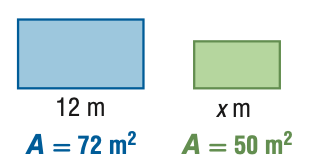Answer the mathemtical geometry problem and directly provide the correct option letter.
Question: For the pair of similar figures, use the given areas to find the scale factor of the blue to the green figure.
Choices: A: \frac { 25 } { 36 } B: \frac { 5 } { 6 } C: \frac { 6 } { 5 } D: \frac { 36 } { 25 } C 